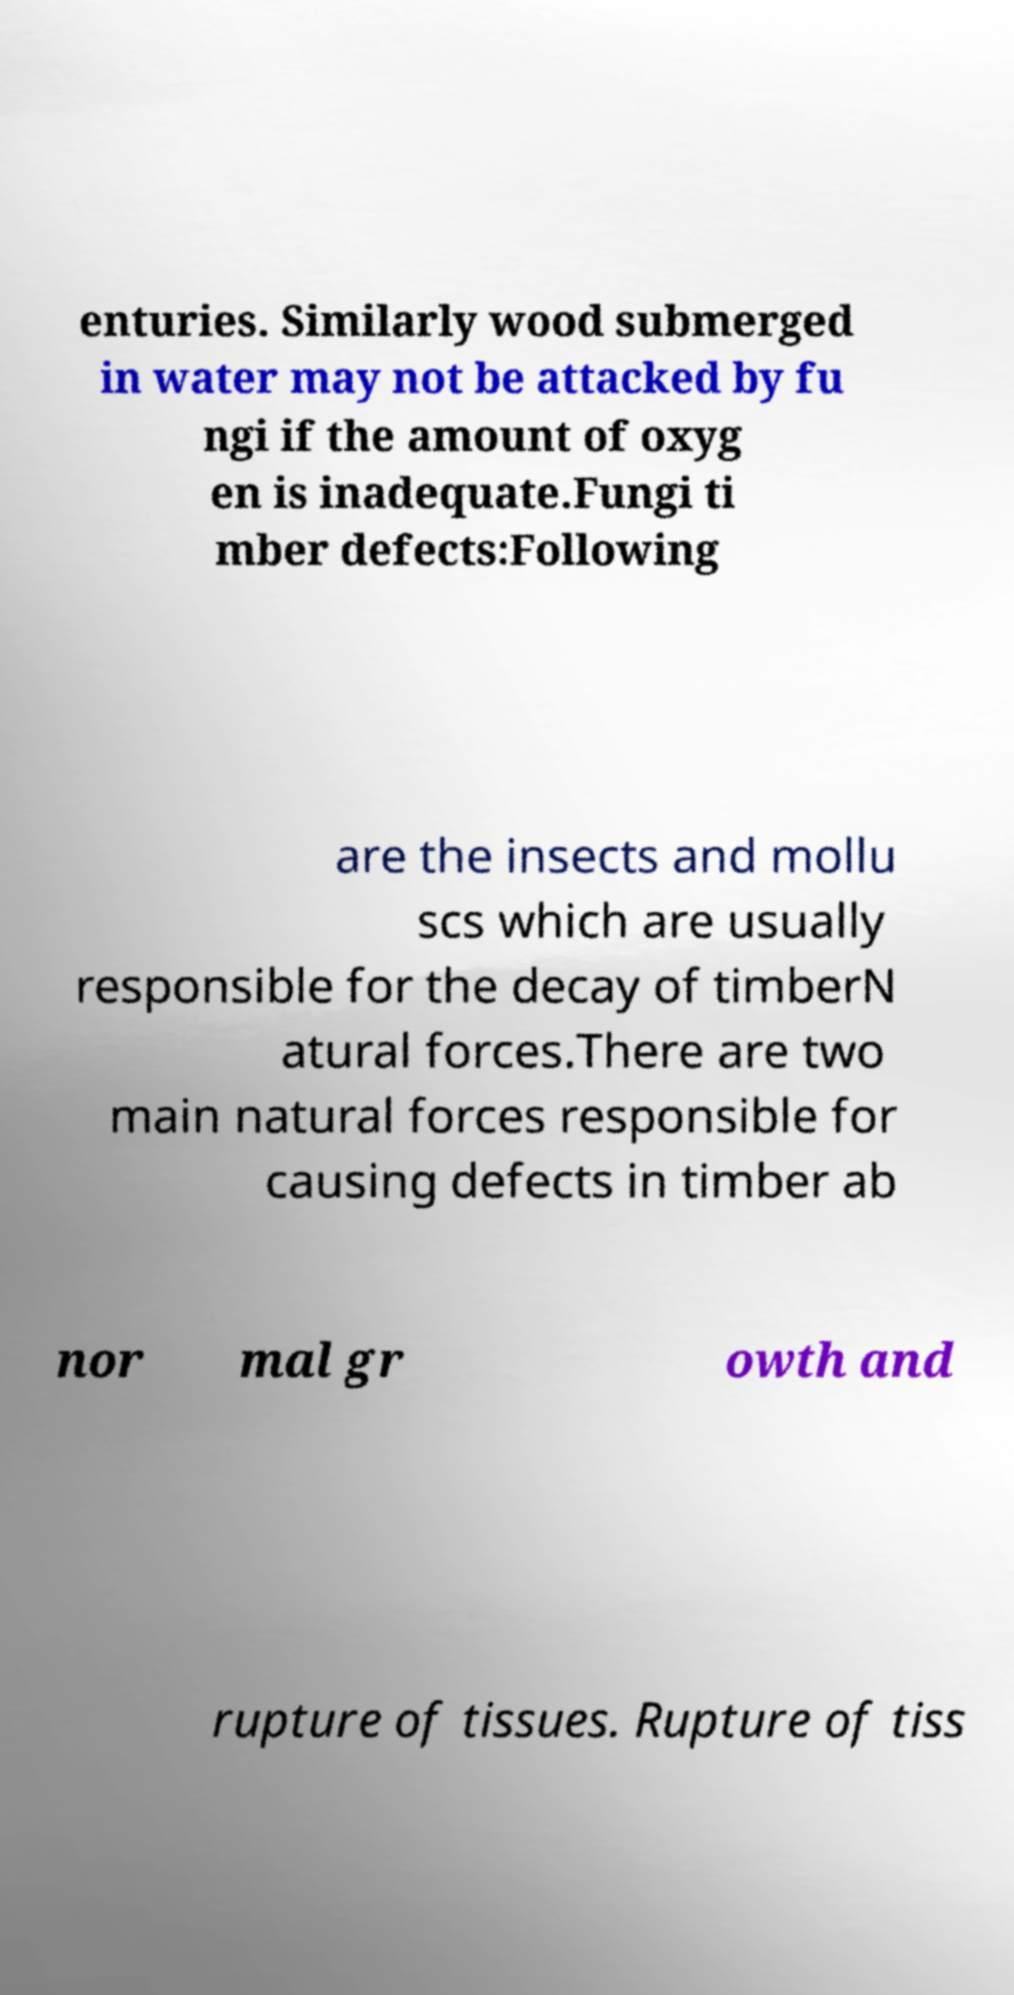For documentation purposes, I need the text within this image transcribed. Could you provide that? enturies. Similarly wood submerged in water may not be attacked by fu ngi if the amount of oxyg en is inadequate.Fungi ti mber defects:Following are the insects and mollu scs which are usually responsible for the decay of timberN atural forces.There are two main natural forces responsible for causing defects in timber ab nor mal gr owth and rupture of tissues. Rupture of tiss 